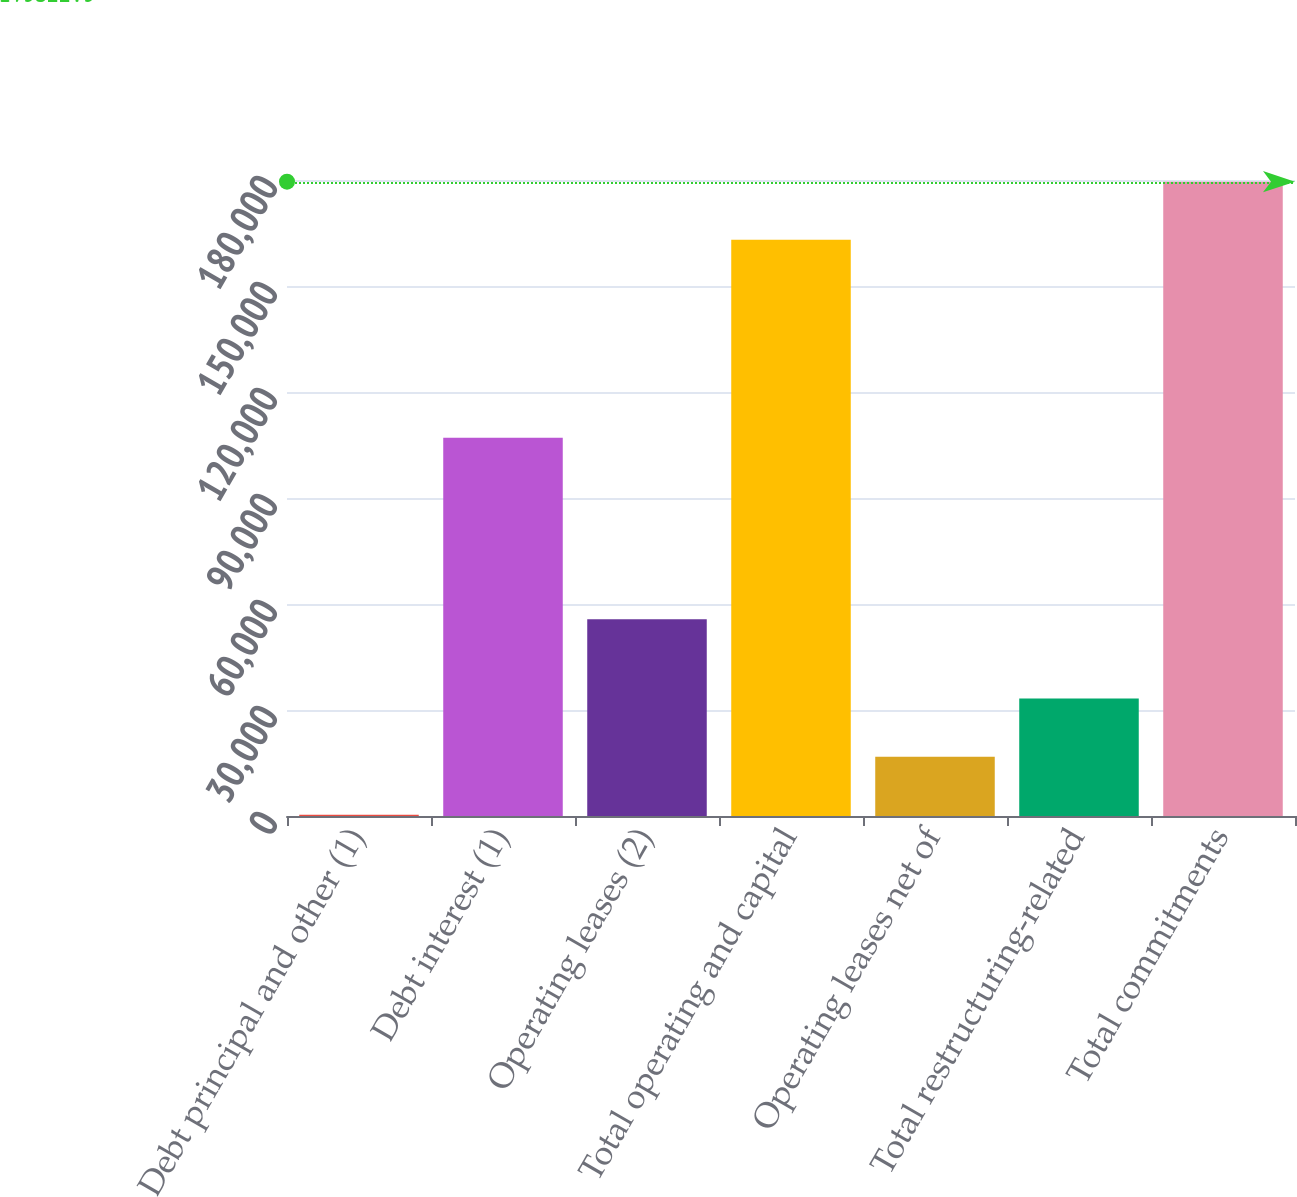<chart> <loc_0><loc_0><loc_500><loc_500><bar_chart><fcel>Debt principal and other (1)<fcel>Debt interest (1)<fcel>Operating leases (2)<fcel>Total operating and capital<fcel>Operating leases net of<fcel>Total restructuring-related<fcel>Total commitments<nl><fcel>340<fcel>107026<fcel>55678<fcel>163066<fcel>16796.9<fcel>33253.8<fcel>179523<nl></chart> 